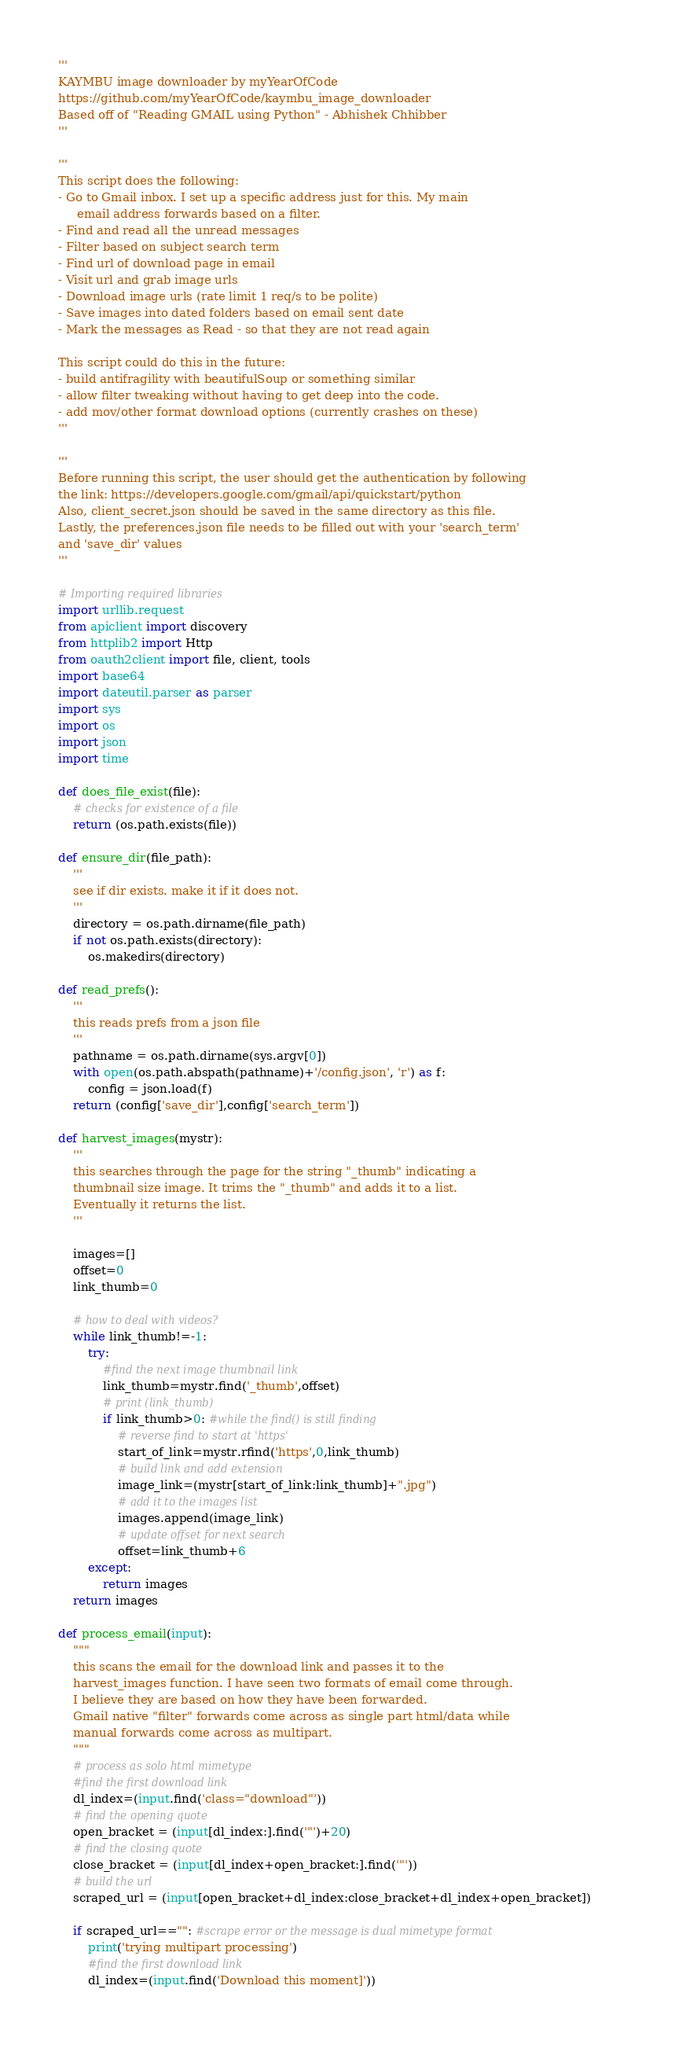Convert code to text. <code><loc_0><loc_0><loc_500><loc_500><_Python_>'''
KAYMBU image downloader by myYearOfCode
https://github.com/myYearOfCode/kaymbu_image_downloader
Based off of "Reading GMAIL using Python" - Abhishek Chhibber
'''

'''
This script does the following:
- Go to Gmail inbox. I set up a specific address just for this. My main 
     email address forwards based on a filter.
- Find and read all the unread messages
- Filter based on subject search term
- Find url of download page in email
- Visit url and grab image urls
- Download image urls (rate limit 1 req/s to be polite)
- Save images into dated folders based on email sent date
- Mark the messages as Read - so that they are not read again 

This script could do this in the future:
- build antifragility with beautifulSoup or something similar
- allow filter tweaking without having to get deep into the code.
- add mov/other format download options (currently crashes on these)
'''

'''
Before running this script, the user should get the authentication by following 
the link: https://developers.google.com/gmail/api/quickstart/python
Also, client_secret.json should be saved in the same directory as this file.
Lastly, the preferences.json file needs to be filled out with your 'search_term'
and 'save_dir' values
'''

# Importing required libraries
import urllib.request
from apiclient import discovery
from httplib2 import Http
from oauth2client import file, client, tools
import base64
import dateutil.parser as parser
import sys
import os
import json
import time

def does_file_exist(file):
    # checks for existence of a file
    return (os.path.exists(file))

def ensure_dir(file_path):
    '''
    see if dir exists. make it if it does not.
    '''
    directory = os.path.dirname(file_path)
    if not os.path.exists(directory):
        os.makedirs(directory)

def read_prefs():
    '''
    this reads prefs from a json file
    '''
    pathname = os.path.dirname(sys.argv[0])    
    with open(os.path.abspath(pathname)+'/config.json', 'r') as f:
        config = json.load(f)
    return (config['save_dir'],config['search_term'])

def harvest_images(mystr):
    '''
    this searches through the page for the string "_thumb" indicating a 
    thumbnail size image. It trims the "_thumb" and adds it to a list. 
    Eventually it returns the list.
    '''

    images=[]
    offset=0
    link_thumb=0
    
    # how to deal with videos?
    while link_thumb!=-1:
        try:
            #find the next image thumbnail link
            link_thumb=mystr.find('_thumb',offset)
            # print (link_thumb)
            if link_thumb>0: #while the find() is still finding
                # reverse find to start at 'https'
                start_of_link=mystr.rfind('https',0,link_thumb)
                # build link and add extension
                image_link=(mystr[start_of_link:link_thumb]+".jpg")
                # add it to the images list
                images.append(image_link)
                # update offset for next search
                offset=link_thumb+6
        except:
            return images
    return images

def process_email(input):
    """ 
    this scans the email for the download link and passes it to the 
    harvest_images function. I have seen two formats of email come through. 
    I believe they are based on how they have been forwarded.
    Gmail native "filter" forwards come across as single part html/data while
    manual forwards come across as multipart.
    """
    # process as solo html mimetype
    #find the first download link
    dl_index=(input.find('class="download"')) 
    # find the opening quote
    open_bracket = (input[dl_index:].find('"')+20)
    # find the closing quote
    close_bracket = (input[dl_index+open_bracket:].find('"'))
    # build the url
    scraped_url = (input[open_bracket+dl_index:close_bracket+dl_index+open_bracket])        

    if scraped_url=="": #scrape error or the message is dual mimetype format
        print('trying multipart processing')
        #find the first download link
        dl_index=(input.find('Download this moment]'))</code> 